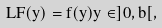<formula> <loc_0><loc_0><loc_500><loc_500>L F ( y ) = f ( y ) y \in ] 0 , b [ ,</formula> 